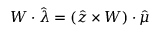<formula> <loc_0><loc_0><loc_500><loc_500>W \cdot \hat { \lambda } = ( \hat { z } \times W ) \cdot \hat { \mu }</formula> 